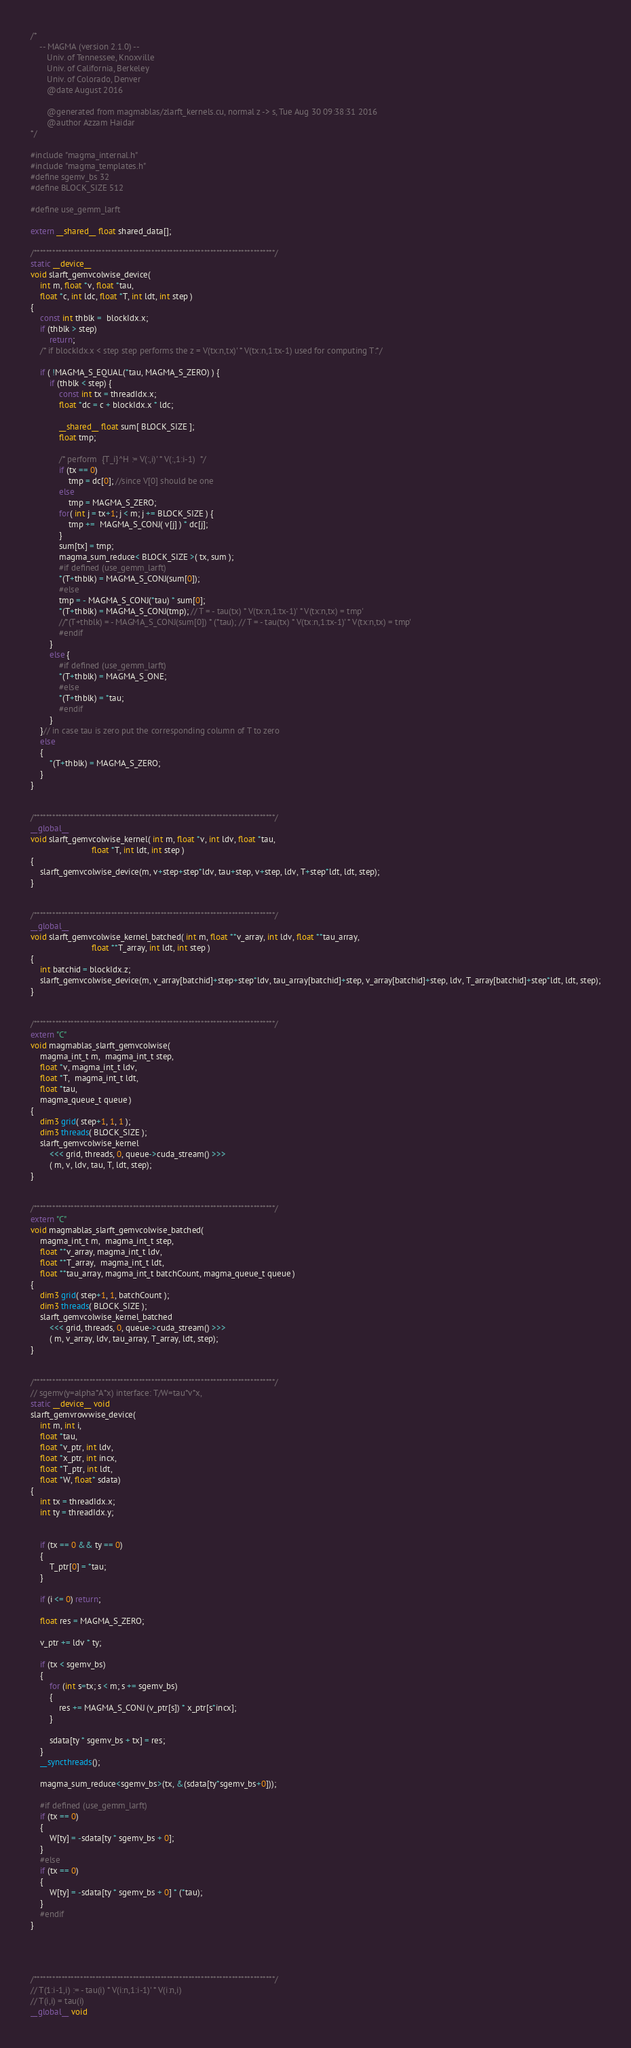Convert code to text. <code><loc_0><loc_0><loc_500><loc_500><_Cuda_>/*
    -- MAGMA (version 2.1.0) --
       Univ. of Tennessee, Knoxville
       Univ. of California, Berkeley
       Univ. of Colorado, Denver
       @date August 2016

       @generated from magmablas/zlarft_kernels.cu, normal z -> s, Tue Aug 30 09:38:31 2016
       @author Azzam Haidar
*/

#include "magma_internal.h"
#include "magma_templates.h"
#define sgemv_bs 32
#define BLOCK_SIZE 512

#define use_gemm_larft

extern __shared__ float shared_data[];

/******************************************************************************/
static __device__
void slarft_gemvcolwise_device(
    int m, float *v, float *tau,
    float *c, int ldc, float *T, int ldt, int step )
{
    const int thblk =  blockIdx.x;
    if (thblk > step)
        return;
    /* if blockIdx.x < step step performs the z = V(tx:n,tx)' * V(tx:n,1:tx-1) used for computing T:*/

    if ( !MAGMA_S_EQUAL(*tau, MAGMA_S_ZERO) ) {
        if (thblk < step) {    
            const int tx = threadIdx.x;
            float *dc = c + blockIdx.x * ldc;
           
            __shared__ float sum[ BLOCK_SIZE ];
            float tmp;
           
            /* perform  {T_i}^H := V(:,i)' * V(:,1:i-1)  */
            if (tx == 0)
                tmp = dc[0]; //since V[0] should be one
            else
                tmp = MAGMA_S_ZERO;
            for( int j = tx+1; j < m; j += BLOCK_SIZE ) {
                tmp +=  MAGMA_S_CONJ( v[j] ) * dc[j];
            }
            sum[tx] = tmp;
            magma_sum_reduce< BLOCK_SIZE >( tx, sum );
            #if defined (use_gemm_larft)
            *(T+thblk) = MAGMA_S_CONJ(sum[0]);
            #else
            tmp = - MAGMA_S_CONJ(*tau) * sum[0]; 
            *(T+thblk) = MAGMA_S_CONJ(tmp); // T = - tau(tx) * V(tx:n,1:tx-1)' * V(tx:n,tx) = tmp'
            //*(T+thblk) = - MAGMA_S_CONJ(sum[0]) * (*tau); // T = - tau(tx) * V(tx:n,1:tx-1)' * V(tx:n,tx) = tmp'
            #endif
        }
        else {
            #if defined (use_gemm_larft)
            *(T+thblk) = MAGMA_S_ONE;
            #else
            *(T+thblk) = *tau;
            #endif
        }
    }// in case tau is zero put the corresponding column of T to zero
    else 
    {
        *(T+thblk) = MAGMA_S_ZERO;
    }
}


/******************************************************************************/
__global__
void slarft_gemvcolwise_kernel( int m, float *v, int ldv, float *tau,
                          float *T, int ldt, int step )
{
    slarft_gemvcolwise_device(m, v+step+step*ldv, tau+step, v+step, ldv, T+step*ldt, ldt, step);
}


/******************************************************************************/
__global__
void slarft_gemvcolwise_kernel_batched( int m, float **v_array, int ldv, float **tau_array,
                          float **T_array, int ldt, int step )
{
    int batchid = blockIdx.z;
    slarft_gemvcolwise_device(m, v_array[batchid]+step+step*ldv, tau_array[batchid]+step, v_array[batchid]+step, ldv, T_array[batchid]+step*ldt, ldt, step);
}


/******************************************************************************/
extern "C" 
void magmablas_slarft_gemvcolwise(
    magma_int_t m,  magma_int_t step,
    float *v, magma_int_t ldv, 
    float *T,  magma_int_t ldt,
    float *tau,
    magma_queue_t queue )
{
    dim3 grid( step+1, 1, 1 );
    dim3 threads( BLOCK_SIZE );
    slarft_gemvcolwise_kernel
        <<< grid, threads, 0, queue->cuda_stream() >>>
        ( m, v, ldv, tau, T, ldt, step);
}


/******************************************************************************/
extern "C" 
void magmablas_slarft_gemvcolwise_batched(
    magma_int_t m,  magma_int_t step,
    float **v_array, magma_int_t ldv, 
    float **T_array,  magma_int_t ldt,
    float **tau_array, magma_int_t batchCount, magma_queue_t queue )
{
    dim3 grid( step+1, 1, batchCount );
    dim3 threads( BLOCK_SIZE );
    slarft_gemvcolwise_kernel_batched
        <<< grid, threads, 0, queue->cuda_stream() >>>
        ( m, v_array, ldv, tau_array, T_array, ldt, step);
}


/******************************************************************************/
// sgemv(y=alpha*A*x) interface: T/W=tau*v*x, 
static __device__ void
slarft_gemvrowwise_device(
    int m, int i,
    float *tau, 
    float *v_ptr, int ldv, 
    float *x_ptr, int incx,
    float *T_ptr, int ldt,
    float *W, float* sdata)
{
    int tx = threadIdx.x; 
    int ty = threadIdx.y; 


    if (tx == 0 && ty == 0)
    {
        T_ptr[0] = *tau;
    } 

    if (i <= 0) return;
    
    float res = MAGMA_S_ZERO;

    v_ptr += ldv * ty;
    
    if (tx < sgemv_bs)
    {
        for (int s=tx; s < m; s += sgemv_bs)
        {
            res += MAGMA_S_CONJ (v_ptr[s]) * x_ptr[s*incx];
        }
    
        sdata[ty * sgemv_bs + tx] = res;
    }
    __syncthreads();

    magma_sum_reduce<sgemv_bs>(tx, &(sdata[ty*sgemv_bs+0]));

    #if defined (use_gemm_larft)
    if (tx == 0)
    {
        W[ty] = -sdata[ty * sgemv_bs + 0];
    } 
    #else
    if (tx == 0)
    {
        W[ty] = -sdata[ty * sgemv_bs + 0] * (*tau);
    }
    #endif 
}




/******************************************************************************/
// T(1:i-1,i) := - tau(i) * V(i:n,1:i-1)' * V(i:n,i)
// T(i,i) = tau(i)
__global__ void</code> 